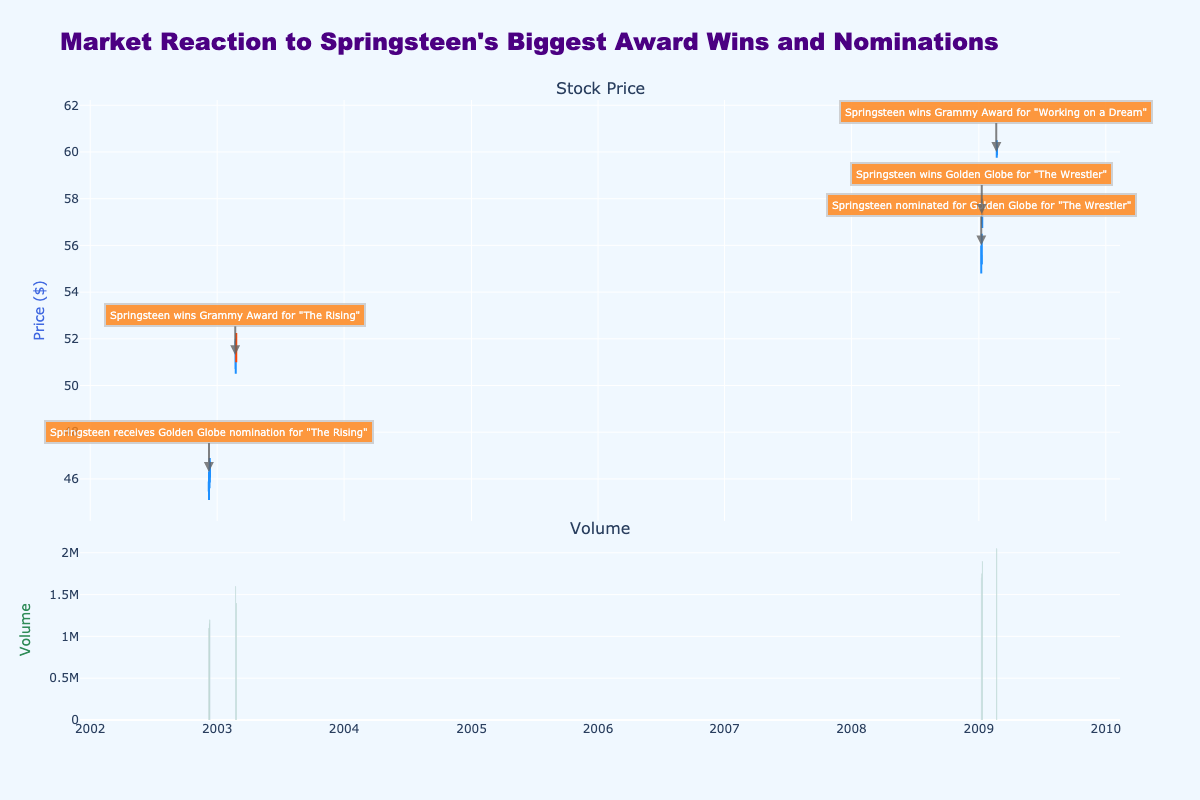What's the title of the plot? The title of the plot is displayed at the upper part of the figure. It reads "Market Reaction to Springsteen's Biggest Award Wins and Nominations."
Answer: Market Reaction to Springsteen's Biggest Award Wins and Nominations What are the colors used for increasing and decreasing candlesticks? By observing the candlestick chart, the color for increasing candlesticks is blue, and the color for decreasing candlesticks is red.
Answer: Blue and Red How did the stock price react to Springsteen's Grammy win for "The Rising" on February 23, 2003? On February 23, 2003, the opening price was 50.15, and the closing price at the end of the day was 50.75, showing an increase. The candlestick is blue, indicating an increase in price.
Answer: Increased Which event had the highest volume traded on the day following the event? By looking at the bar chart at the bottom and cross-referencing the highlighted events, Springsteen's Grammy win on February 22, 2009, has the highest volume traded, with the volume being greater on the following day, February 23, 2009.
Answer: Grammy Award for "Working on a Dream" What was the opening price on the day after Springsteen won the Golden Globe for "The Wrestler"? Springsteen won the Golden Globe for "The Wrestler" on January 11, 2009. The opening price on January 12, 2009, can be found in the table. The opening price was 56.95.
Answer: 56.95 Compare the stock price movement after Springsteen's Grammy win on February 23, 2003, and February 22, 2009. For February 23, 2003, the stock price increased from the open to close (50.15 to 50.75). For February 23, 2009, the price again increased from the open to close (59.90 to 60.25). Both days following the Grammy wins show an increase in stock prices.
Answer: Both increased What was the closing price on the date Springsteen received a Golden Globe nomination for "The Rising"? Springsteen received the Golden Globe nomination for "The Rising" on December 9, 2002. Checking the data for that date, the closing price was 45.85.
Answer: 45.85 Did the stock price increase or decrease more significantly following the Grammy win on February 22, 2009, compared to the Golden Globe win on January 11, 2009? For February 22, 2009, the stock closed at 59.90 from an open of 59.10 (an increase of 0.80). For January 11, 2009, it closed at 56.95 from an open of 56.85 (an increase of 0.10). Thus, the price increase following the Grammy win was more significant.
Answer: Increase after Grammy win Calculate the average opening and closing prices for the days shown in the plot. Sum all the opening prices and divide by the number of days, then do the same with closing prices. The sum of opening prices: 364.35, and there are 9 days. The average opening price is 364.35/9 ≈ 40.48. The sum of closing prices: 361.97, the average closing price is 361.97/9 ≈ 40.22.
Answer: Average opening: 40.48, average closing: 40.22 